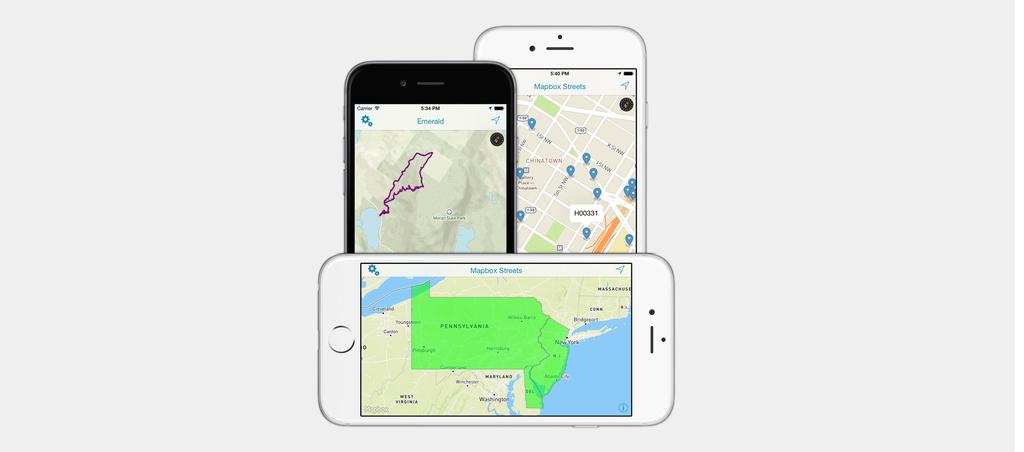What state is highlighted in the bottom phone?
Your answer should be compact. Pennsylvania. Which place it is?
Provide a succinct answer. Pennsylvania. 